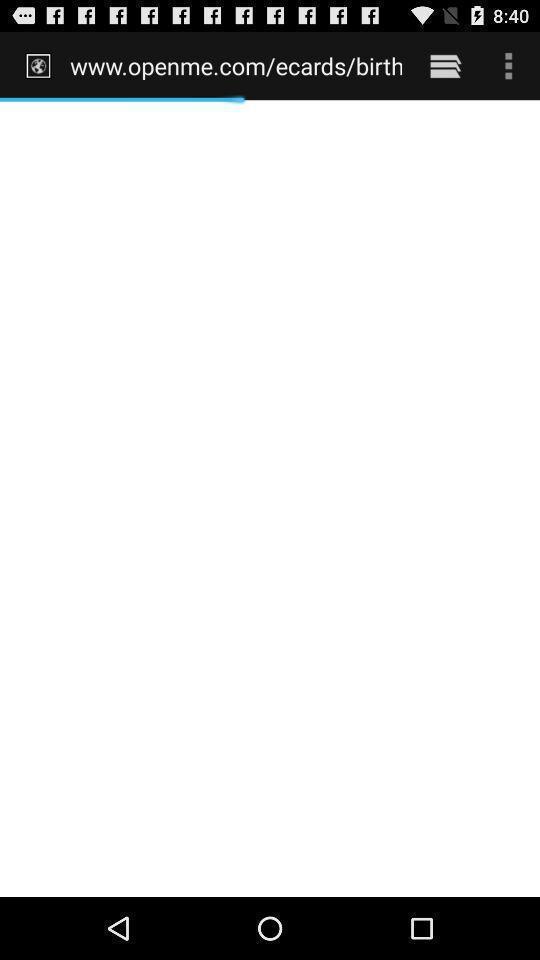What details can you identify in this image? Screen shows a blank page. 